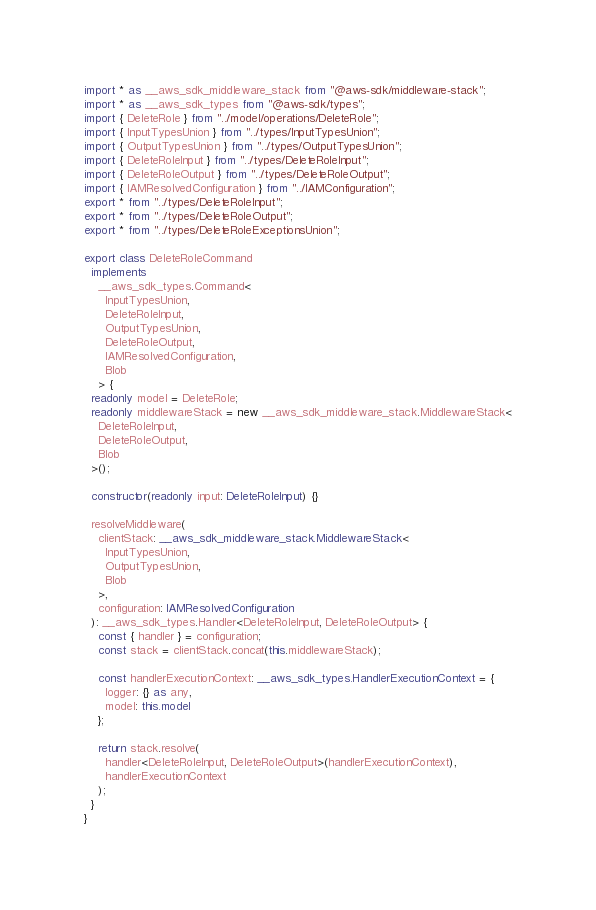Convert code to text. <code><loc_0><loc_0><loc_500><loc_500><_TypeScript_>import * as __aws_sdk_middleware_stack from "@aws-sdk/middleware-stack";
import * as __aws_sdk_types from "@aws-sdk/types";
import { DeleteRole } from "../model/operations/DeleteRole";
import { InputTypesUnion } from "../types/InputTypesUnion";
import { OutputTypesUnion } from "../types/OutputTypesUnion";
import { DeleteRoleInput } from "../types/DeleteRoleInput";
import { DeleteRoleOutput } from "../types/DeleteRoleOutput";
import { IAMResolvedConfiguration } from "../IAMConfiguration";
export * from "../types/DeleteRoleInput";
export * from "../types/DeleteRoleOutput";
export * from "../types/DeleteRoleExceptionsUnion";

export class DeleteRoleCommand
  implements
    __aws_sdk_types.Command<
      InputTypesUnion,
      DeleteRoleInput,
      OutputTypesUnion,
      DeleteRoleOutput,
      IAMResolvedConfiguration,
      Blob
    > {
  readonly model = DeleteRole;
  readonly middlewareStack = new __aws_sdk_middleware_stack.MiddlewareStack<
    DeleteRoleInput,
    DeleteRoleOutput,
    Blob
  >();

  constructor(readonly input: DeleteRoleInput) {}

  resolveMiddleware(
    clientStack: __aws_sdk_middleware_stack.MiddlewareStack<
      InputTypesUnion,
      OutputTypesUnion,
      Blob
    >,
    configuration: IAMResolvedConfiguration
  ): __aws_sdk_types.Handler<DeleteRoleInput, DeleteRoleOutput> {
    const { handler } = configuration;
    const stack = clientStack.concat(this.middlewareStack);

    const handlerExecutionContext: __aws_sdk_types.HandlerExecutionContext = {
      logger: {} as any,
      model: this.model
    };

    return stack.resolve(
      handler<DeleteRoleInput, DeleteRoleOutput>(handlerExecutionContext),
      handlerExecutionContext
    );
  }
}
</code> 